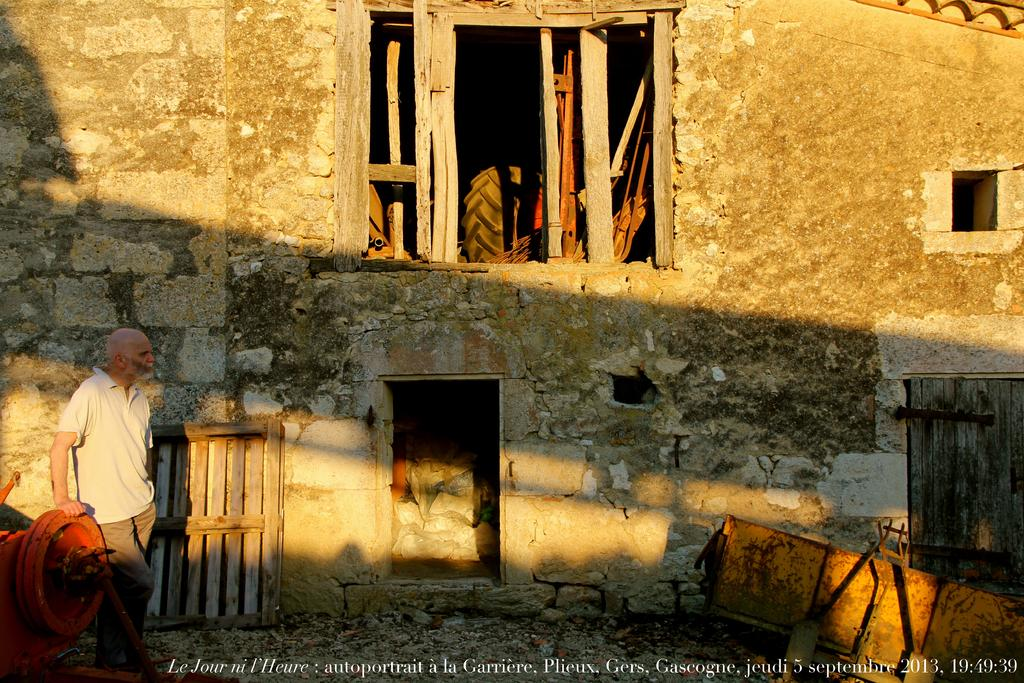<image>
Present a compact description of the photo's key features. A man walking past a house as photographed on September 5 2013. 